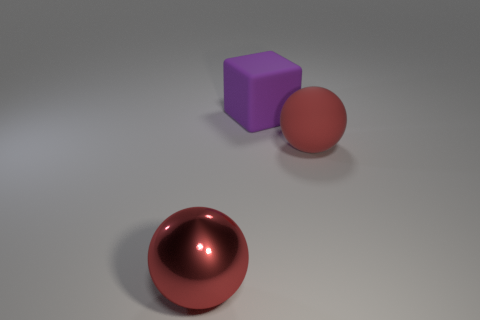Add 2 small gray balls. How many objects exist? 5 Subtract all balls. How many objects are left? 1 Add 3 metal things. How many metal things are left? 4 Add 3 large shiny spheres. How many large shiny spheres exist? 4 Subtract 0 yellow cylinders. How many objects are left? 3 Subtract all large yellow matte things. Subtract all large red metallic balls. How many objects are left? 2 